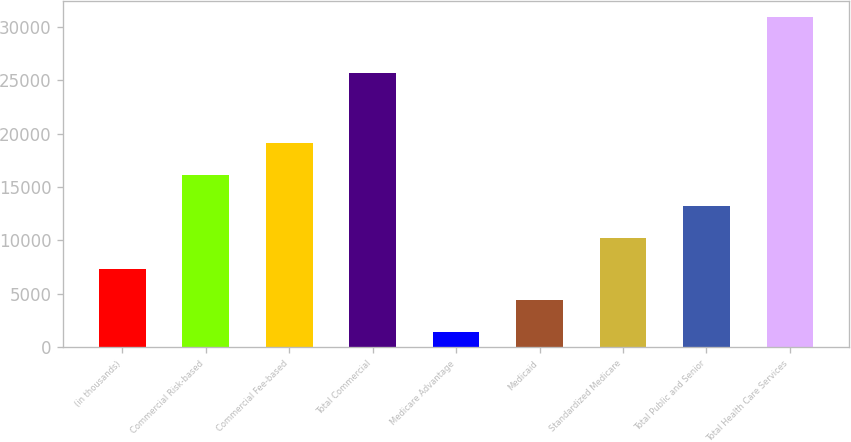Convert chart. <chart><loc_0><loc_0><loc_500><loc_500><bar_chart><fcel>(in thousands)<fcel>Commercial Risk-based<fcel>Commercial Fee-based<fcel>Total Commercial<fcel>Medicare Advantage<fcel>Medicaid<fcel>Standardized Medicare<fcel>Total Public and Senior<fcel>Total Health Care Services<nl><fcel>7333<fcel>16165<fcel>19109<fcel>25700<fcel>1445<fcel>4389<fcel>10277<fcel>13221<fcel>30885<nl></chart> 